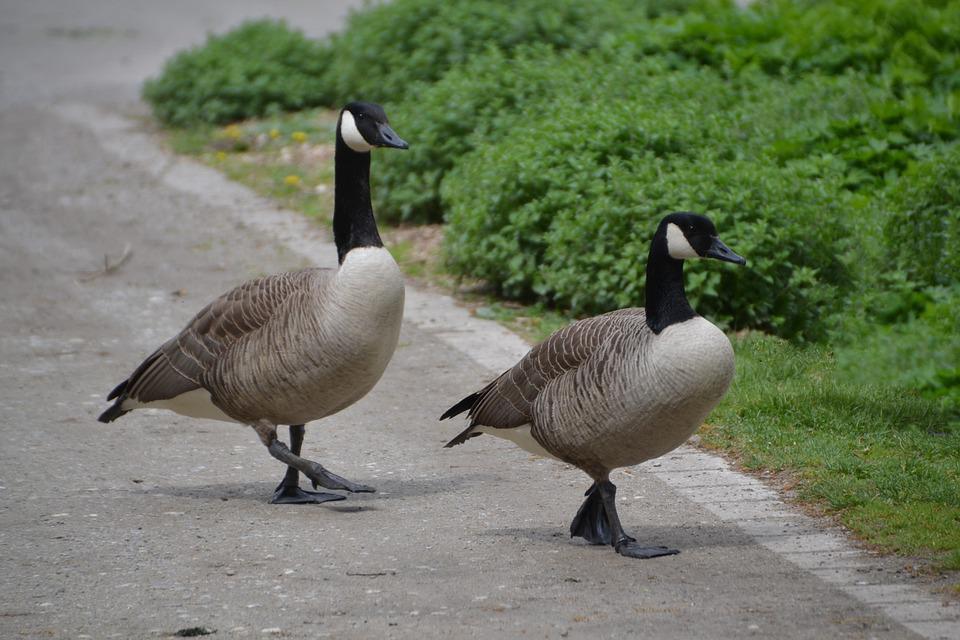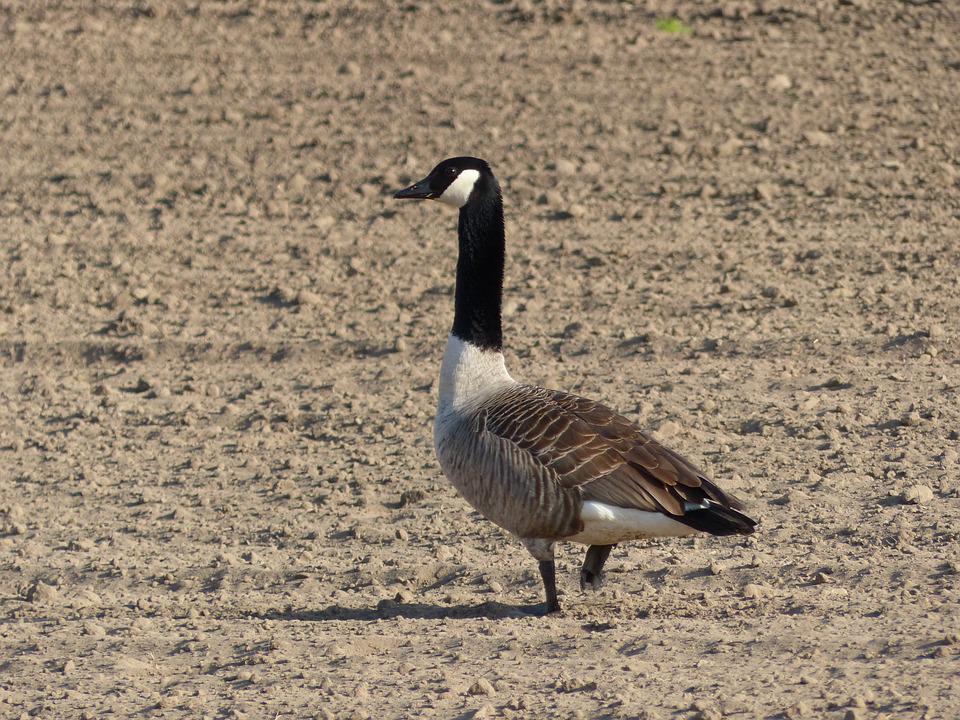The first image is the image on the left, the second image is the image on the right. Examine the images to the left and right. Is the description "There are two birds in the picture on the right." accurate? Answer yes or no. No. 